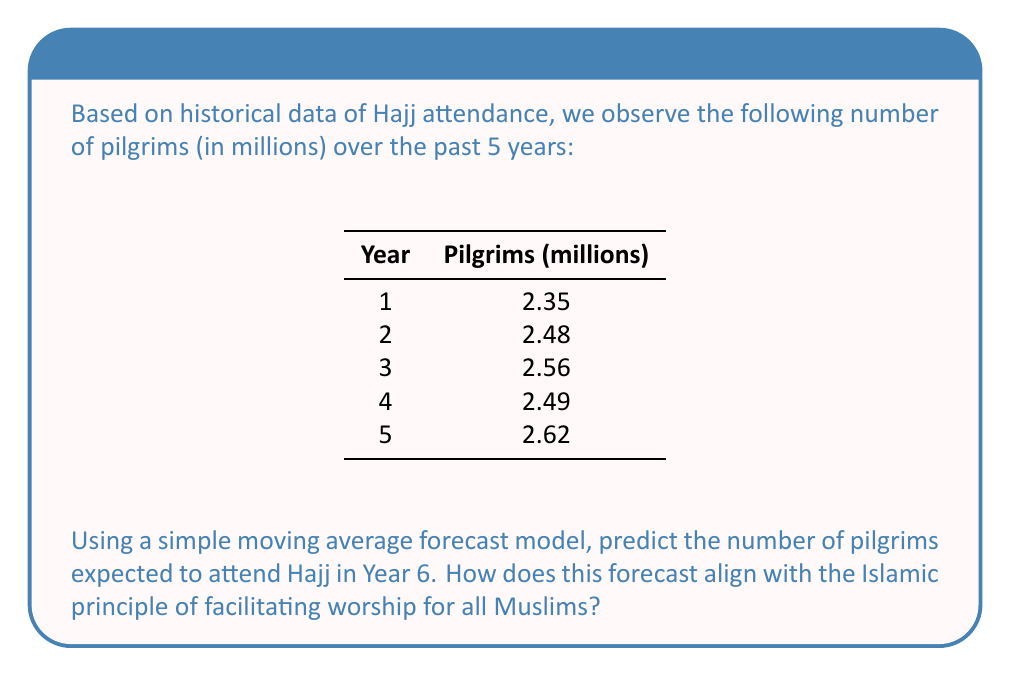Can you solve this math problem? To solve this problem, we'll use a 3-year simple moving average (SMA) forecast model. This method is appropriate for short-term forecasting and can help smooth out fluctuations in the data.

Step 1: Calculate the 3-year SMA for the available data:
$$SMA_3 = \frac{\text{Sum of 3 consecutive years}}{\text{Number of years (3)}}$$

For Year 4: $$SMA_3 = \frac{2.35 + 2.48 + 2.56}{3} = 2.463$$
For Year 5: $$SMA_3 = \frac{2.48 + 2.56 + 2.49}{3} = 2.51$$

Step 2: Calculate the forecast for Year 6:
$$\text{Forecast for Year 6} = \frac{2.56 + 2.49 + 2.62}{3} = 2.557$$

Step 3: Interpret the result:
The forecast predicts 2.557 million pilgrims for Year 6, showing a slight increase from the previous year.

From an Islamic perspective, this forecast aligns with the principle of facilitating worship (taysir) by allowing authorities to prepare adequately for the increasing number of pilgrims. It helps in planning accommodation, transportation, and safety measures, ensuring that more Muslims can fulfill their religious obligation of Hajj comfortably and safely.
Answer: 2.557 million pilgrims 